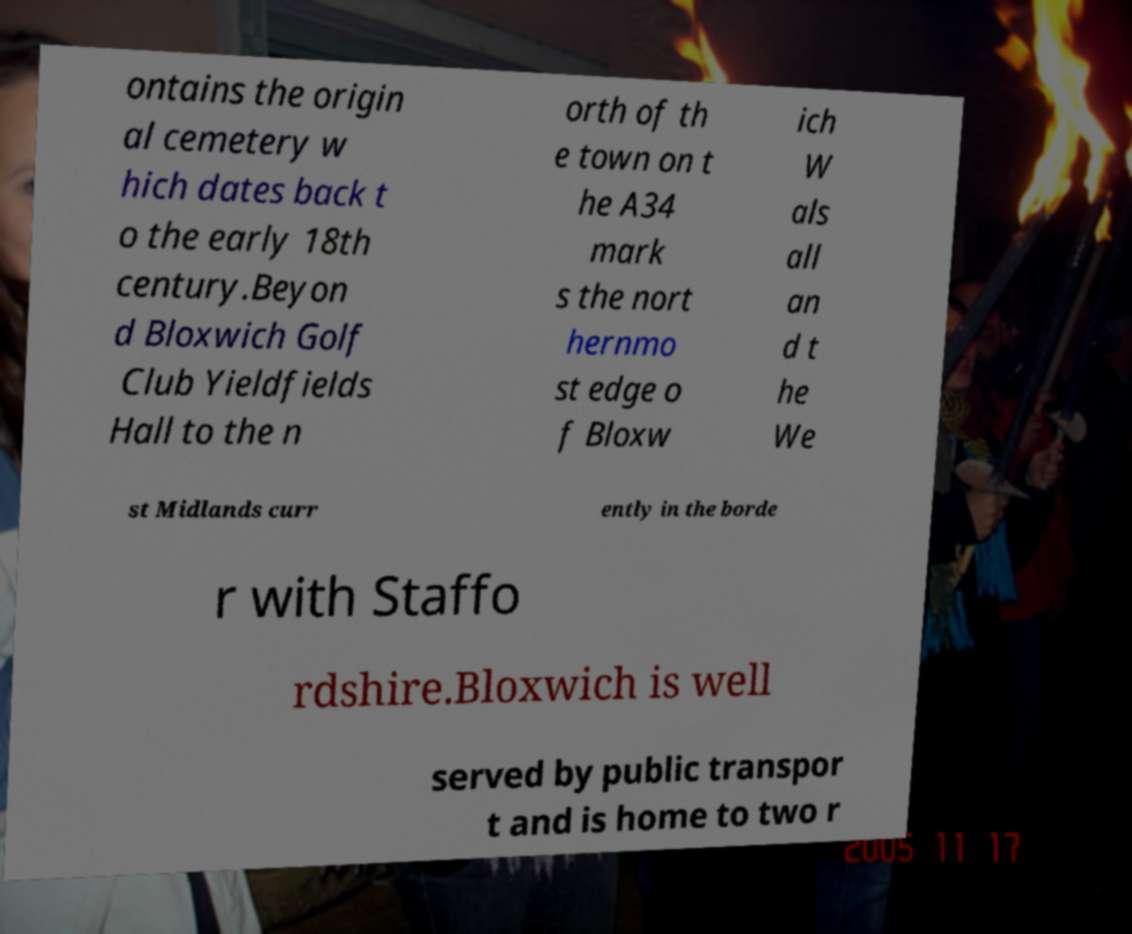Please read and relay the text visible in this image. What does it say? ontains the origin al cemetery w hich dates back t o the early 18th century.Beyon d Bloxwich Golf Club Yieldfields Hall to the n orth of th e town on t he A34 mark s the nort hernmo st edge o f Bloxw ich W als all an d t he We st Midlands curr ently in the borde r with Staffo rdshire.Bloxwich is well served by public transpor t and is home to two r 